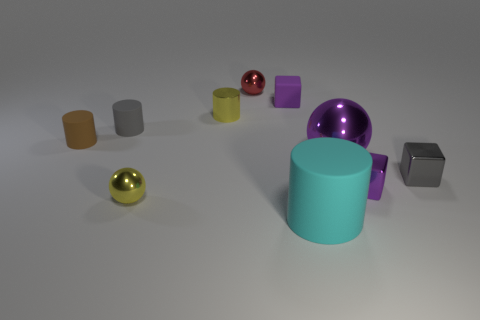Is the number of yellow spheres that are behind the tiny purple rubber object the same as the number of small purple rubber cubes?
Make the answer very short. No. Is the material of the small red sphere the same as the purple ball?
Your response must be concise. Yes. There is a cube that is in front of the yellow metallic cylinder and behind the purple metallic cube; how big is it?
Offer a very short reply. Small. What number of objects are the same size as the purple sphere?
Your answer should be compact. 1. What size is the yellow metallic object that is behind the yellow shiny object that is in front of the small gray metallic thing?
Make the answer very short. Small. Does the gray object on the right side of the small purple matte block have the same shape as the small purple object left of the large cyan thing?
Ensure brevity in your answer.  Yes. There is a thing that is both on the left side of the yellow cylinder and in front of the purple metal sphere; what is its color?
Your answer should be very brief. Yellow. Are there any small rubber cylinders of the same color as the big cylinder?
Provide a succinct answer. No. The small ball that is behind the gray metal object is what color?
Your answer should be compact. Red. There is a purple cube that is left of the cyan cylinder; are there any yellow shiny balls that are right of it?
Keep it short and to the point. No. 